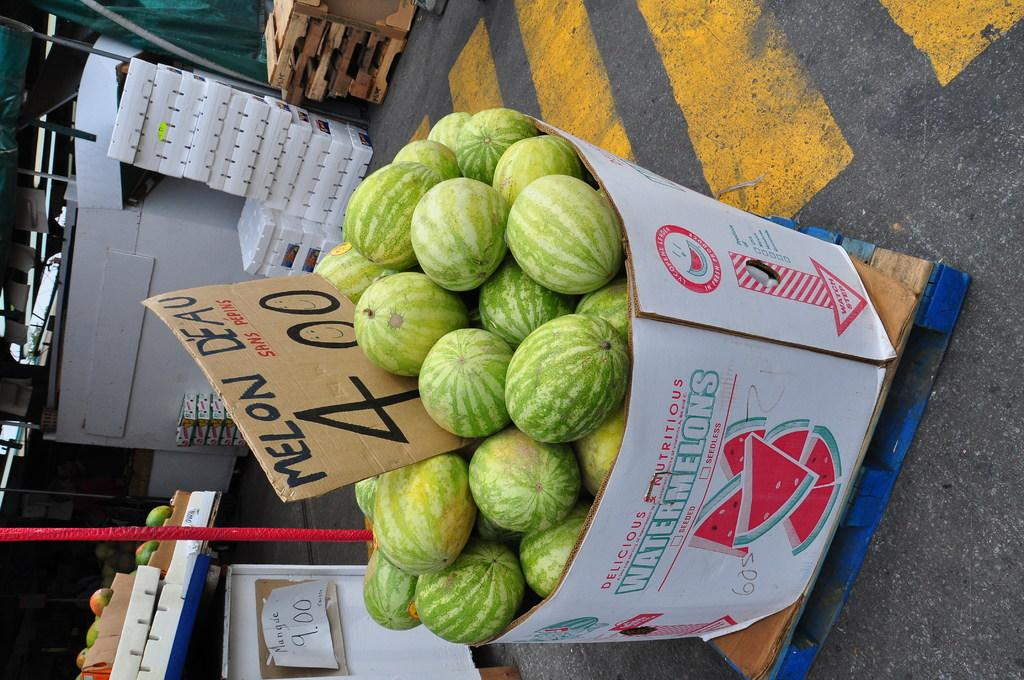What type of fruit is in the box in the image? There are watermelons in a box in the image. Where is the box with watermelons located? The box is on a road in the image. What can be seen on the left side of the image? There are boxes and a wooden table on the left side of the image. What structures are present in the image? There are poles in the image. What type of rock can be seen in the image? There is no rock present in the image. What is the weather like in the image? The provided facts do not give any information about the weather in the image. 